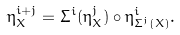Convert formula to latex. <formula><loc_0><loc_0><loc_500><loc_500>\eta ^ { i + j } _ { X } = \Sigma ^ { i } ( \eta ^ { j } _ { X } ) \circ \eta ^ { i } _ { \Sigma ^ { j } ( X ) } .</formula> 